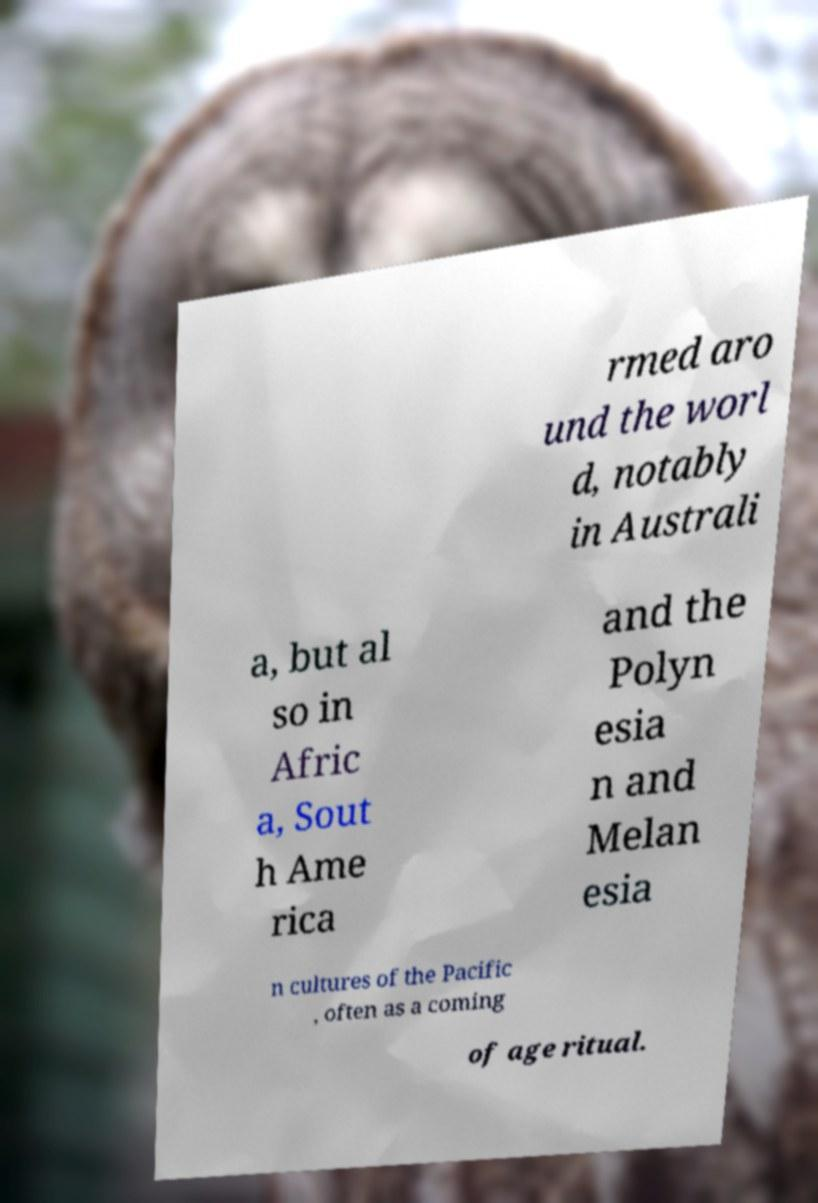There's text embedded in this image that I need extracted. Can you transcribe it verbatim? rmed aro und the worl d, notably in Australi a, but al so in Afric a, Sout h Ame rica and the Polyn esia n and Melan esia n cultures of the Pacific , often as a coming of age ritual. 